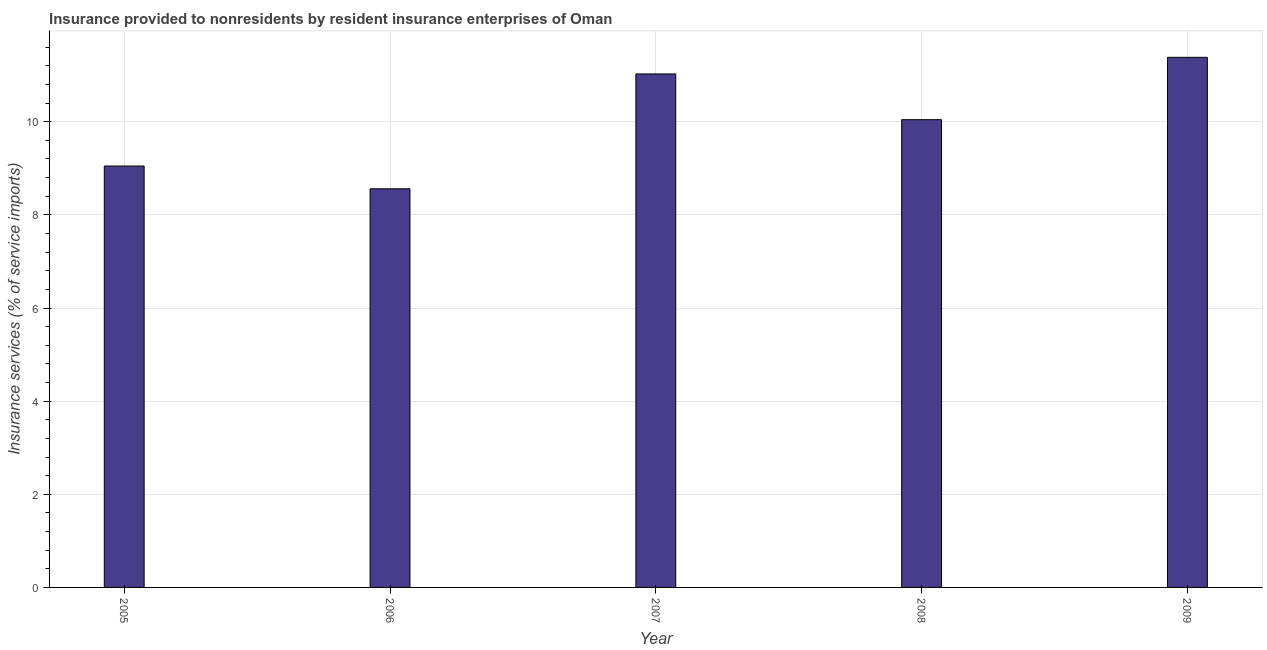Does the graph contain any zero values?
Offer a very short reply. No. What is the title of the graph?
Keep it short and to the point. Insurance provided to nonresidents by resident insurance enterprises of Oman. What is the label or title of the Y-axis?
Keep it short and to the point. Insurance services (% of service imports). What is the insurance and financial services in 2005?
Keep it short and to the point. 9.05. Across all years, what is the maximum insurance and financial services?
Provide a short and direct response. 11.38. Across all years, what is the minimum insurance and financial services?
Your answer should be very brief. 8.56. What is the sum of the insurance and financial services?
Your answer should be compact. 50.06. What is the difference between the insurance and financial services in 2005 and 2007?
Provide a succinct answer. -1.98. What is the average insurance and financial services per year?
Your answer should be very brief. 10.01. What is the median insurance and financial services?
Your answer should be very brief. 10.04. In how many years, is the insurance and financial services greater than 4.4 %?
Your answer should be compact. 5. What is the ratio of the insurance and financial services in 2005 to that in 2009?
Your answer should be very brief. 0.8. Is the difference between the insurance and financial services in 2006 and 2007 greater than the difference between any two years?
Your answer should be very brief. No. What is the difference between the highest and the second highest insurance and financial services?
Keep it short and to the point. 0.36. What is the difference between the highest and the lowest insurance and financial services?
Keep it short and to the point. 2.82. In how many years, is the insurance and financial services greater than the average insurance and financial services taken over all years?
Provide a succinct answer. 3. How many bars are there?
Offer a terse response. 5. Are all the bars in the graph horizontal?
Ensure brevity in your answer.  No. What is the difference between two consecutive major ticks on the Y-axis?
Your answer should be very brief. 2. What is the Insurance services (% of service imports) in 2005?
Make the answer very short. 9.05. What is the Insurance services (% of service imports) in 2006?
Give a very brief answer. 8.56. What is the Insurance services (% of service imports) in 2007?
Keep it short and to the point. 11.03. What is the Insurance services (% of service imports) in 2008?
Your response must be concise. 10.04. What is the Insurance services (% of service imports) of 2009?
Give a very brief answer. 11.38. What is the difference between the Insurance services (% of service imports) in 2005 and 2006?
Provide a succinct answer. 0.49. What is the difference between the Insurance services (% of service imports) in 2005 and 2007?
Keep it short and to the point. -1.98. What is the difference between the Insurance services (% of service imports) in 2005 and 2008?
Give a very brief answer. -1. What is the difference between the Insurance services (% of service imports) in 2005 and 2009?
Offer a very short reply. -2.33. What is the difference between the Insurance services (% of service imports) in 2006 and 2007?
Offer a terse response. -2.47. What is the difference between the Insurance services (% of service imports) in 2006 and 2008?
Offer a terse response. -1.48. What is the difference between the Insurance services (% of service imports) in 2006 and 2009?
Ensure brevity in your answer.  -2.82. What is the difference between the Insurance services (% of service imports) in 2007 and 2008?
Provide a short and direct response. 0.98. What is the difference between the Insurance services (% of service imports) in 2007 and 2009?
Make the answer very short. -0.36. What is the difference between the Insurance services (% of service imports) in 2008 and 2009?
Make the answer very short. -1.34. What is the ratio of the Insurance services (% of service imports) in 2005 to that in 2006?
Offer a terse response. 1.06. What is the ratio of the Insurance services (% of service imports) in 2005 to that in 2007?
Offer a terse response. 0.82. What is the ratio of the Insurance services (% of service imports) in 2005 to that in 2008?
Provide a succinct answer. 0.9. What is the ratio of the Insurance services (% of service imports) in 2005 to that in 2009?
Your answer should be very brief. 0.8. What is the ratio of the Insurance services (% of service imports) in 2006 to that in 2007?
Offer a terse response. 0.78. What is the ratio of the Insurance services (% of service imports) in 2006 to that in 2008?
Make the answer very short. 0.85. What is the ratio of the Insurance services (% of service imports) in 2006 to that in 2009?
Provide a succinct answer. 0.75. What is the ratio of the Insurance services (% of service imports) in 2007 to that in 2008?
Provide a succinct answer. 1.1. What is the ratio of the Insurance services (% of service imports) in 2007 to that in 2009?
Give a very brief answer. 0.97. What is the ratio of the Insurance services (% of service imports) in 2008 to that in 2009?
Offer a very short reply. 0.88. 